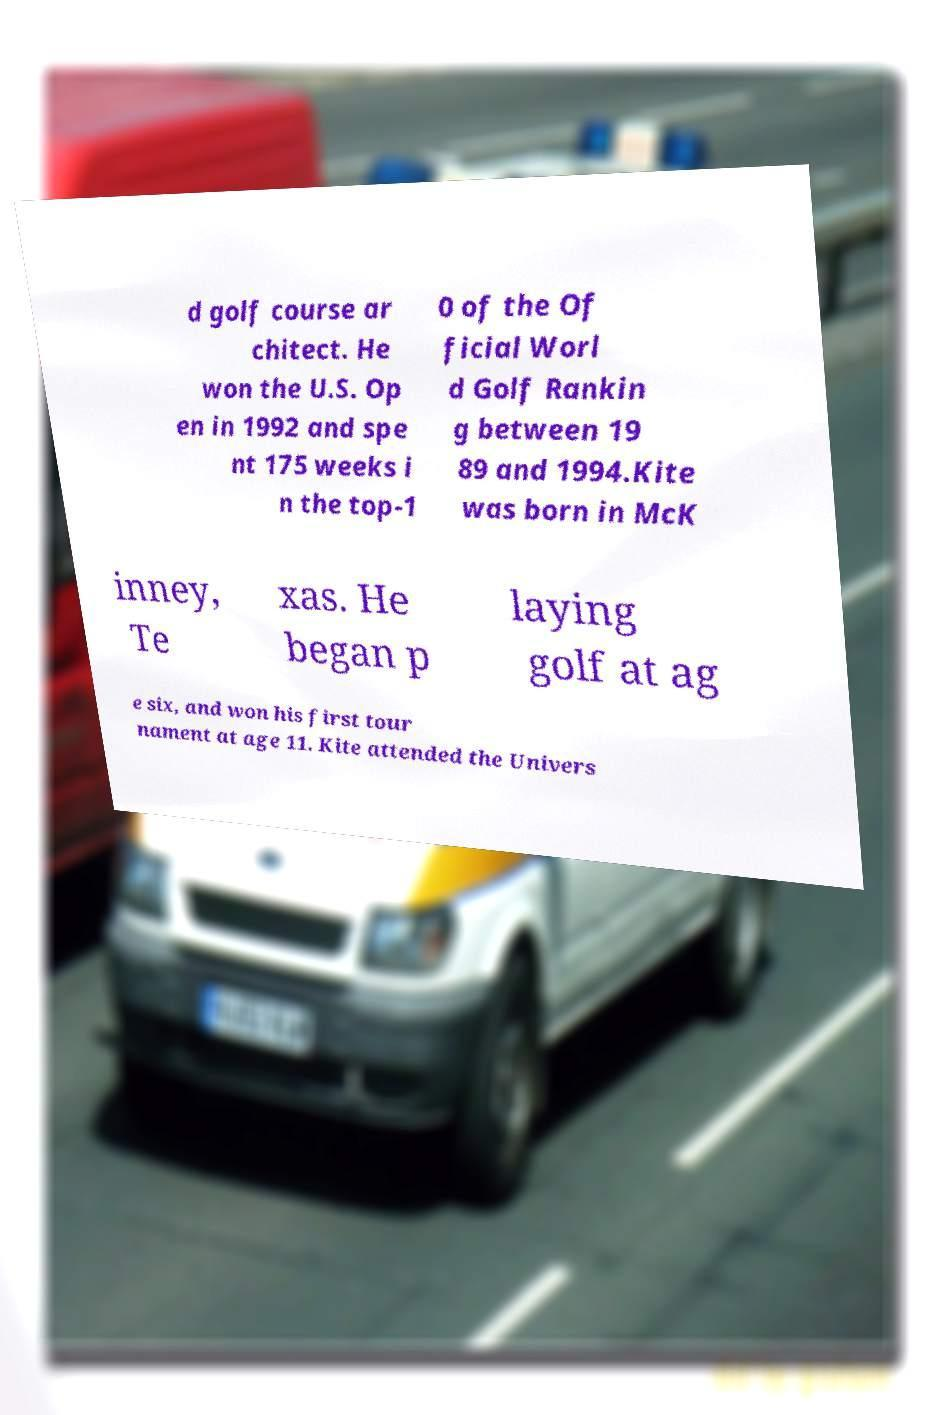Can you read and provide the text displayed in the image?This photo seems to have some interesting text. Can you extract and type it out for me? d golf course ar chitect. He won the U.S. Op en in 1992 and spe nt 175 weeks i n the top-1 0 of the Of ficial Worl d Golf Rankin g between 19 89 and 1994.Kite was born in McK inney, Te xas. He began p laying golf at ag e six, and won his first tour nament at age 11. Kite attended the Univers 